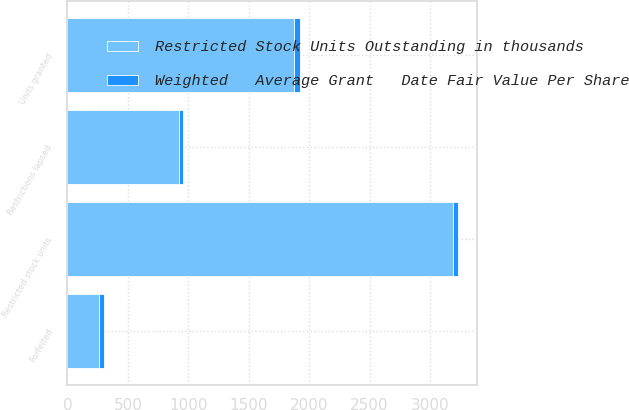<chart> <loc_0><loc_0><loc_500><loc_500><stacked_bar_chart><ecel><fcel>Restricted stock units<fcel>Units granted<fcel>Restrictions lapsed<fcel>Forfeited<nl><fcel>Restricted Stock Units Outstanding in thousands<fcel>3188<fcel>1876<fcel>920<fcel>261<nl><fcel>Weighted   Average Grant   Date Fair Value Per Share<fcel>43.46<fcel>47.38<fcel>36.02<fcel>42.1<nl></chart> 